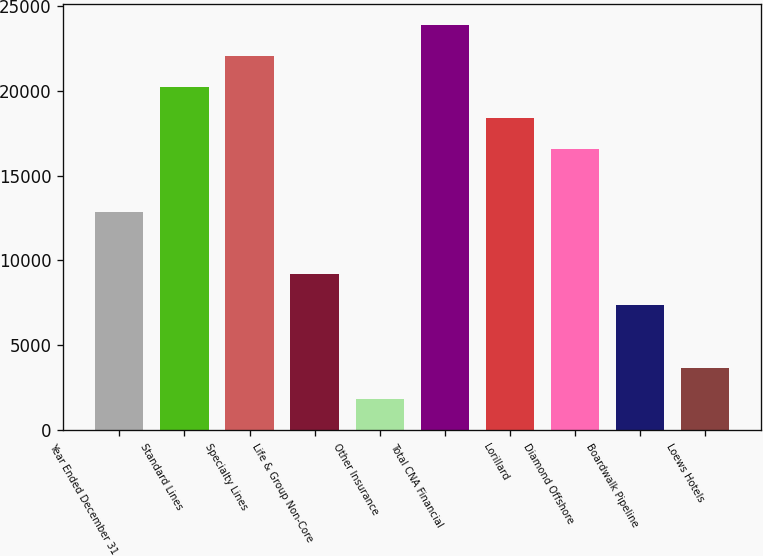Convert chart to OTSL. <chart><loc_0><loc_0><loc_500><loc_500><bar_chart><fcel>Year Ended December 31<fcel>Standard Lines<fcel>Specialty Lines<fcel>Life & Group Non-Core<fcel>Other Insurance<fcel>Total CNA Financial<fcel>Lorillard<fcel>Diamond Offshore<fcel>Boardwalk Pipeline<fcel>Loews Hotels<nl><fcel>12868.4<fcel>20217.2<fcel>22054.4<fcel>9194<fcel>1845.2<fcel>23891.6<fcel>18380<fcel>16542.8<fcel>7356.8<fcel>3682.4<nl></chart> 